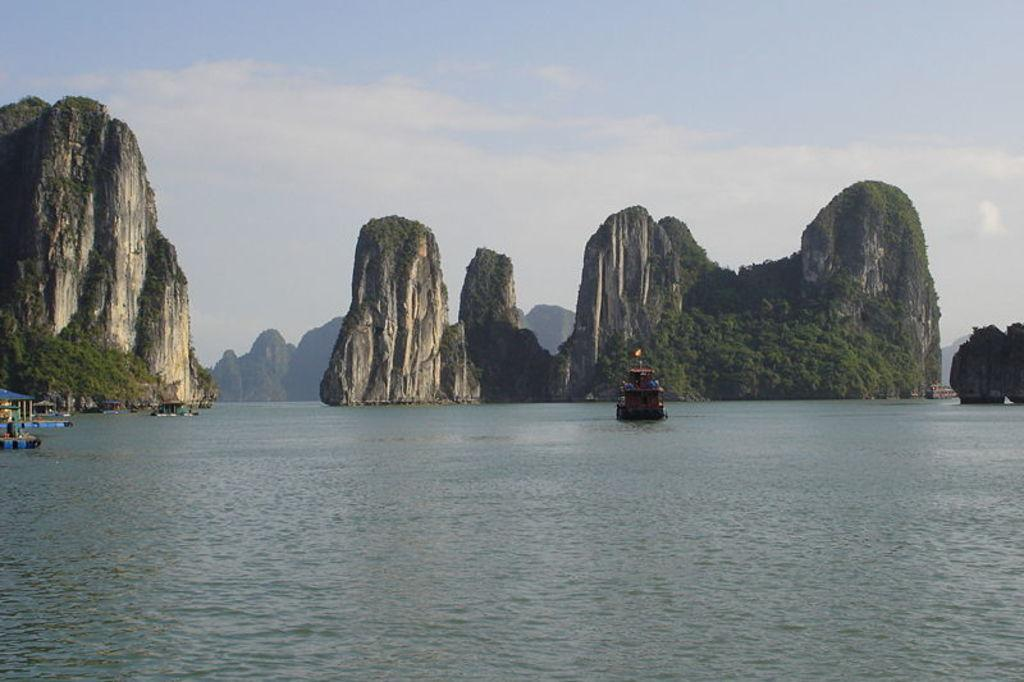What is the main subject of the image? The main subject of the image is water. What is present in the water? There are boats in the water. Can you describe the boats in the image? There are more boats visible in the background. What else can be seen in the image besides the water and boats? The sky is visible in the image. How many slaves are visible in the image? There are no slaves present in the image. What type of elbow is used to steer the boats in the image? There are no elbows mentioned or visible in the image; boats are typically steered using a rudder or tiller. 